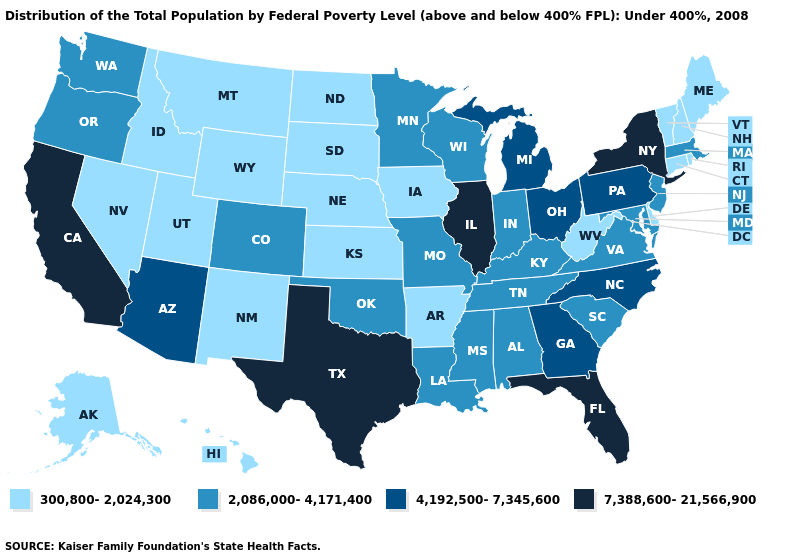What is the highest value in the MidWest ?
Answer briefly. 7,388,600-21,566,900. What is the lowest value in the South?
Answer briefly. 300,800-2,024,300. Does Minnesota have the lowest value in the USA?
Short answer required. No. Does Kansas have the same value as Wisconsin?
Answer briefly. No. What is the lowest value in the USA?
Concise answer only. 300,800-2,024,300. What is the lowest value in the MidWest?
Short answer required. 300,800-2,024,300. What is the highest value in the USA?
Short answer required. 7,388,600-21,566,900. Which states have the lowest value in the USA?
Concise answer only. Alaska, Arkansas, Connecticut, Delaware, Hawaii, Idaho, Iowa, Kansas, Maine, Montana, Nebraska, Nevada, New Hampshire, New Mexico, North Dakota, Rhode Island, South Dakota, Utah, Vermont, West Virginia, Wyoming. Does Indiana have a higher value than North Dakota?
Give a very brief answer. Yes. Does Louisiana have a higher value than Idaho?
Keep it brief. Yes. Among the states that border New Hampshire , does Maine have the highest value?
Answer briefly. No. Name the states that have a value in the range 4,192,500-7,345,600?
Short answer required. Arizona, Georgia, Michigan, North Carolina, Ohio, Pennsylvania. What is the value of Rhode Island?
Answer briefly. 300,800-2,024,300. Does Delaware have the lowest value in the South?
Concise answer only. Yes. 